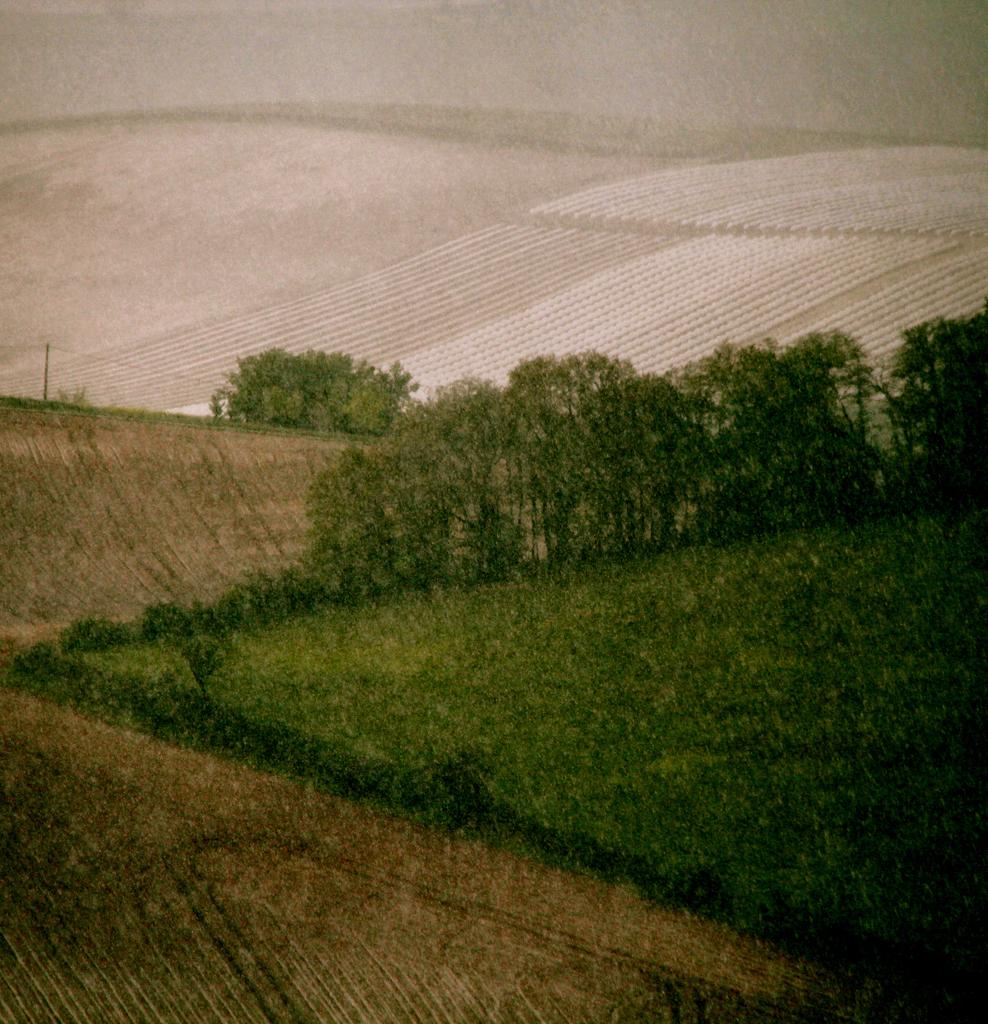What type of vegetation can be seen in the image? There are trees in the image. What else can be seen on the ground in the image? There is grass in the image. How many divisions can be seen in the ant's leg in the image? There are no ants or legs present in the image; it only features trees and grass. 